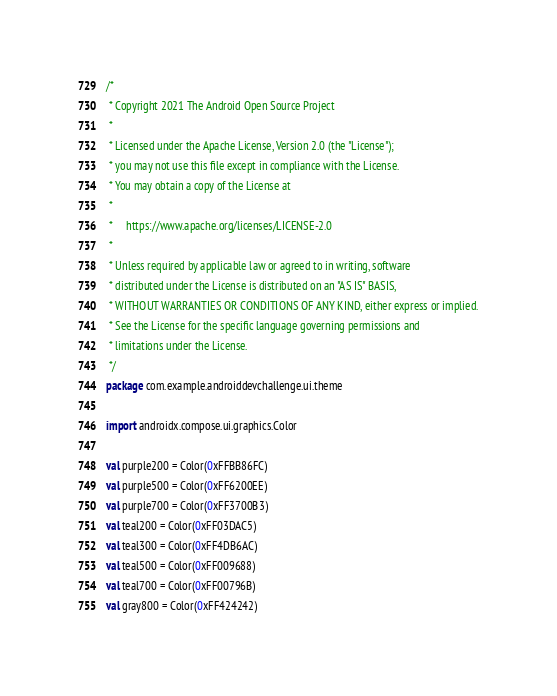Convert code to text. <code><loc_0><loc_0><loc_500><loc_500><_Kotlin_>/*
 * Copyright 2021 The Android Open Source Project
 *
 * Licensed under the Apache License, Version 2.0 (the "License");
 * you may not use this file except in compliance with the License.
 * You may obtain a copy of the License at
 *
 *     https://www.apache.org/licenses/LICENSE-2.0
 *
 * Unless required by applicable law or agreed to in writing, software
 * distributed under the License is distributed on an "AS IS" BASIS,
 * WITHOUT WARRANTIES OR CONDITIONS OF ANY KIND, either express or implied.
 * See the License for the specific language governing permissions and
 * limitations under the License.
 */
package com.example.androiddevchallenge.ui.theme

import androidx.compose.ui.graphics.Color

val purple200 = Color(0xFFBB86FC)
val purple500 = Color(0xFF6200EE)
val purple700 = Color(0xFF3700B3)
val teal200 = Color(0xFF03DAC5)
val teal300 = Color(0xFF4DB6AC)
val teal500 = Color(0xFF009688)
val teal700 = Color(0xFF00796B)
val gray800 = Color(0xFF424242)
</code> 